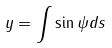<formula> <loc_0><loc_0><loc_500><loc_500>y = \int \sin \psi d s</formula> 